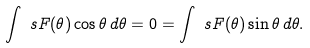Convert formula to latex. <formula><loc_0><loc_0><loc_500><loc_500>\int _ { \ } s F ( \theta ) \cos \theta \, d \theta = 0 = \int _ { \ } s F ( \theta ) \sin \theta \, d \theta .</formula> 